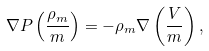<formula> <loc_0><loc_0><loc_500><loc_500>\nabla P \left ( \frac { \rho _ { m } } { m } \right ) = - \rho _ { m } \nabla \left ( \frac { V } { m } \right ) ,</formula> 